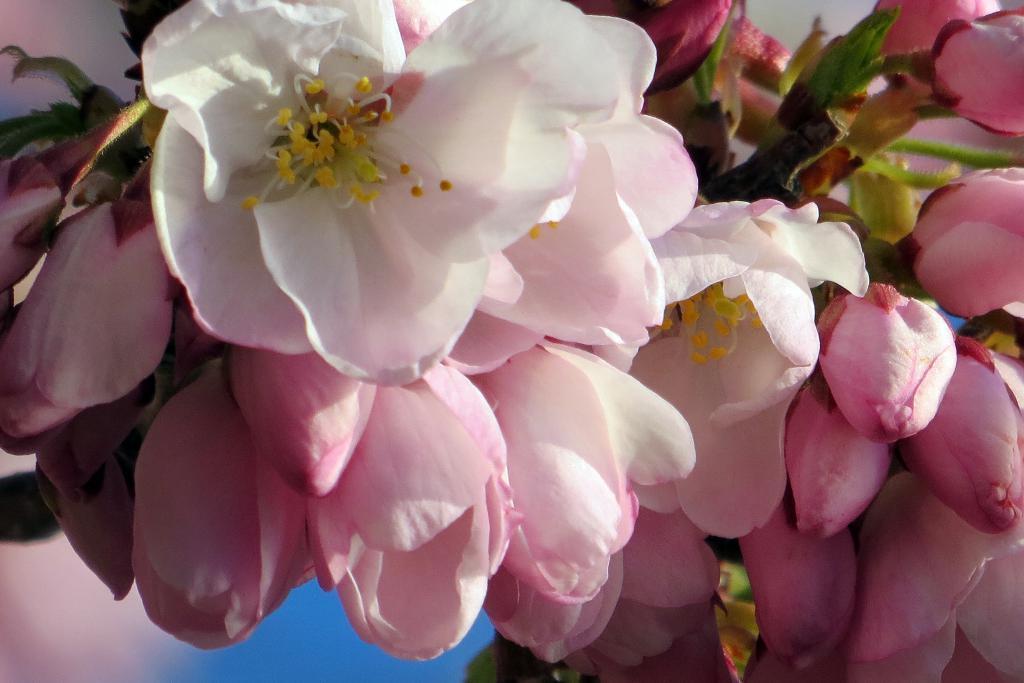How would you summarize this image in a sentence or two? In this image in the foreground there are some flowers, and the background is blurred. 